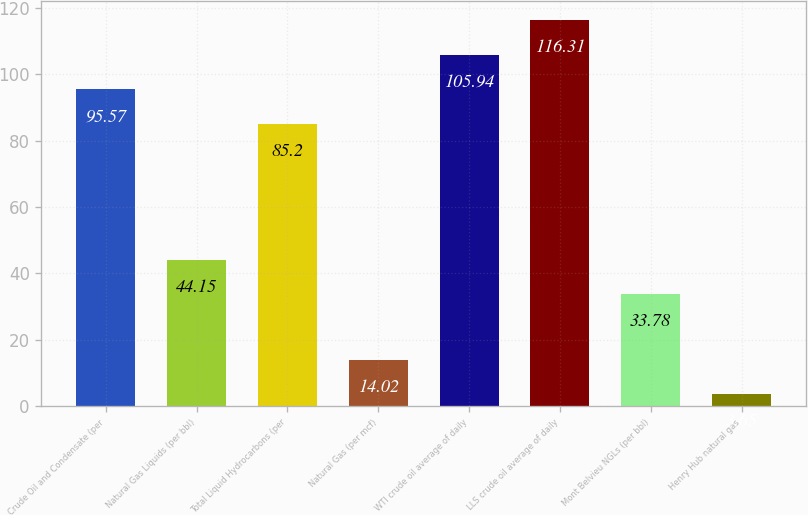Convert chart to OTSL. <chart><loc_0><loc_0><loc_500><loc_500><bar_chart><fcel>Crude Oil and Condensate (per<fcel>Natural Gas Liquids (per bbl)<fcel>Total Liquid Hydrocarbons (per<fcel>Natural Gas (per mcf)<fcel>WTI crude oil average of daily<fcel>LLS crude oil average of daily<fcel>Mont Belvieu NGLs (per bbl)<fcel>Henry Hub natural gas<nl><fcel>95.57<fcel>44.15<fcel>85.2<fcel>14.02<fcel>105.94<fcel>116.31<fcel>33.78<fcel>3.65<nl></chart> 